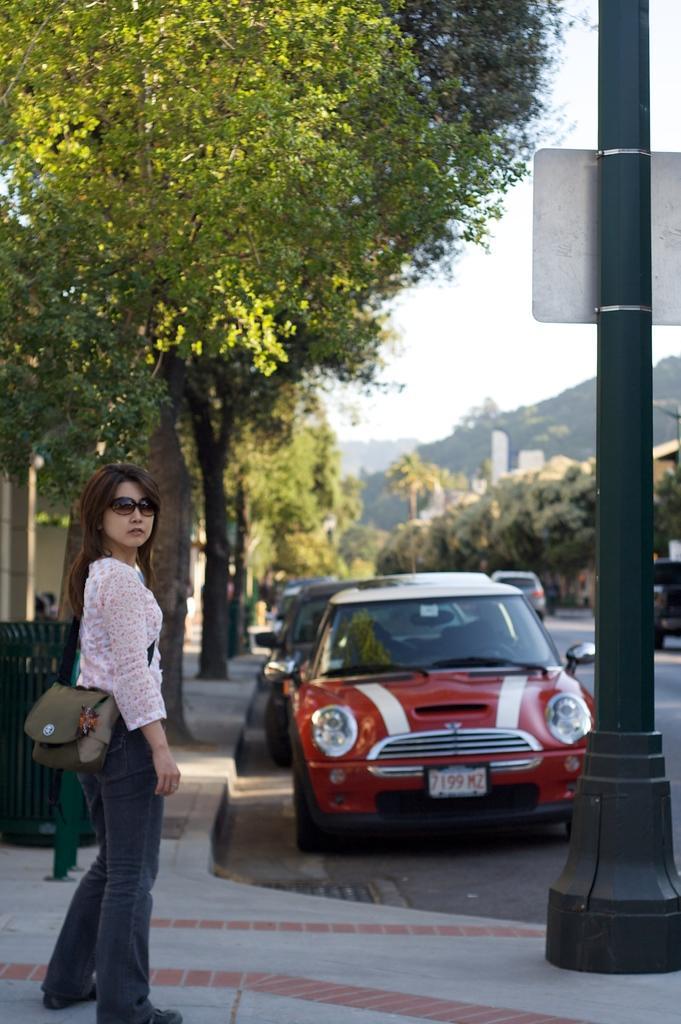Please provide a concise description of this image. In this image there is a girl standing on the floor by wearing the bag. On the right side there is a road on which there are few cars. There are trees on the footpath. In the background it looks like a hill. On the right side there is a pole on the footpath. To the pole there is a board. 